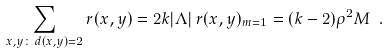<formula> <loc_0><loc_0><loc_500><loc_500>\sum _ { x , y \colon \, d ( x , y ) = 2 } r ( x , y ) = 2 k | \Lambda | \, r ( x , y ) _ { m = 1 } = ( k - 2 ) \rho ^ { 2 } M \ .</formula> 